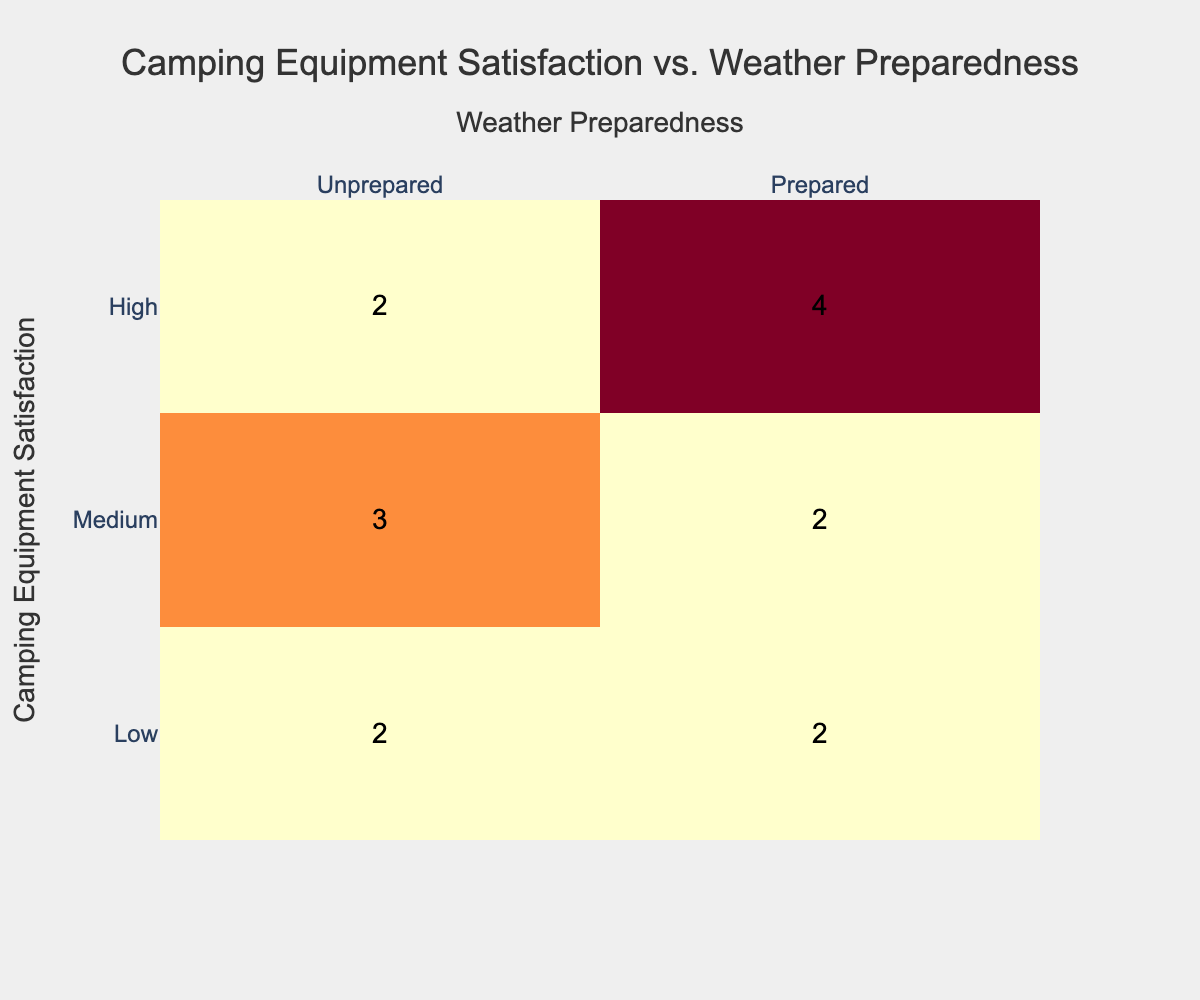What is the total number of campers who reported high satisfaction with their equipment? To find this, we look at the "High" row in the Camping Equipment Satisfaction column. The corresponding values in the Weather Preparedness column are "Prepared" (4 times) and "Unprepared" (3 times). Summing them, we have a total of 4 + 3 = 7 campers.
Answer: 7 How many campers were unprepared but satisfied only at a medium level? In the "Medium" row, we see that the corresponding value under "Unprepared" is 3, indicating that 3 campers reported being unprepared while having a medium level of satisfaction.
Answer: 3 Is the number of satisfied (high) campers greater than the number of unprepared (low) campers? The number of satisfied (high) campers is 7, while the number of unprepared (low) campers is 3. Since 7 is greater than 3, the answer is yes.
Answer: Yes What is the total count of campers who were prepared regardless of their satisfaction level? We need to sum the counts of "Prepared" from all satisfaction levels. From the "Low" row, there are 2 prepared, from "Medium," there are 4, and from "High," there are 4, leading to the total count of 2 + 4 + 4 = 10 campers who are prepared.
Answer: 10 What percentage of campers with low satisfaction reported being prepared? We first identify the total number of low satisfaction campers, which is 4 (2 prepared + 2 unprepared). The number who are prepared is 2. The percentage is calculated as (2/4) * 100 = 50%.
Answer: 50% How many more campers reported high equipment satisfaction than those who were unprepared across all satisfaction levels? We know that there are 7 campers who reported high satisfaction and there are 5 unprepared campers in total (2 from Low, 3 from Medium, and 3 from High). Thus, the difference is 7 - 5 = 2 more campers reporting high satisfaction.
Answer: 2 What is the overall satisfaction level of campers who were prepared? To find this, we consider the totals from the Prepared column. The campers reporting High satisfaction is 4, Medium is 4, and Low is 2. Summing these gives us 4 + 4 + 2 = 10 campers who are prepared, indicating they have a mix of high, medium, and low satisfaction.
Answer: Mixed levels How many campers reported being unprepared and satisfied at a medium level? In the "Medium" row under "Unprepared," we see the count is 3. Therefore, 3 campers reported being unprepared while having medium satisfaction.
Answer: 3 Was there at least one camper who satisfied both being low in equipment satisfaction and being prepared? Looking at the "Low" row in Weather Preparedness, the count is 2, implying that there were unprepared campers among those with low satisfaction. Hence, there was no count of low satisfaction campers being prepared.
Answer: No 